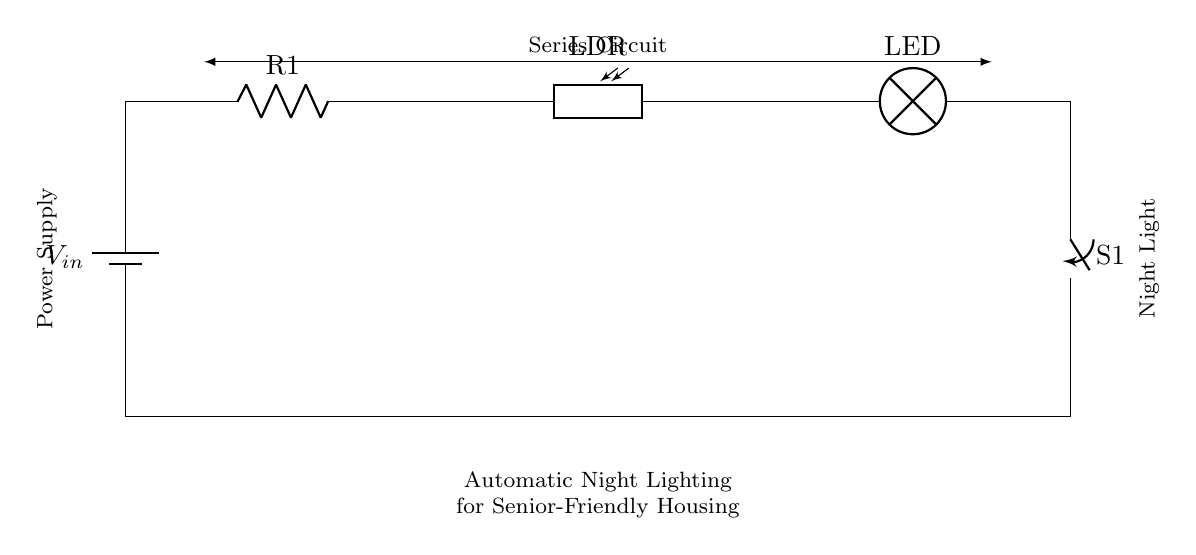What is the power supply component in the circuit? The power supply component is represented by the battery symbol, which provides the necessary voltage for the circuit's operation.
Answer: Battery What type of circuit configuration is depicted in this diagram? The circuit is a series configuration, indicated by the components being connected one after another in a single path.
Answer: Series What component acts as the light source in this circuit? The component serving as the light source is the LED. It emits light when current flows through it in response to changes in light levels detected by the photoresistor.
Answer: LED Which component detects light levels? The component that detects light levels is the photoresistor, also known as LDR, which changes resistance based on the intensity of ambient light.
Answer: Photoresistor What happens to the LED when it gets dark? When it gets dark, the resistance of the photoresistor increases, allowing more current to flow through the circuit to light the LED.
Answer: Lights up What is the role of the switch in this circuit? The switch controls the flow of current; when closed, it allows current to flow through the circuit, energizing the LED, while when open, it interrupts the current flow and turns off the light.
Answer: Control current How does the photoresistor affect the LED's operation? The photoresistor's resistance changes with light conditions; in low light, it allows more current to flow, turning the LED on, while in bright light, its high resistance reduces current, turning the LED off.
Answer: Controls brightness 